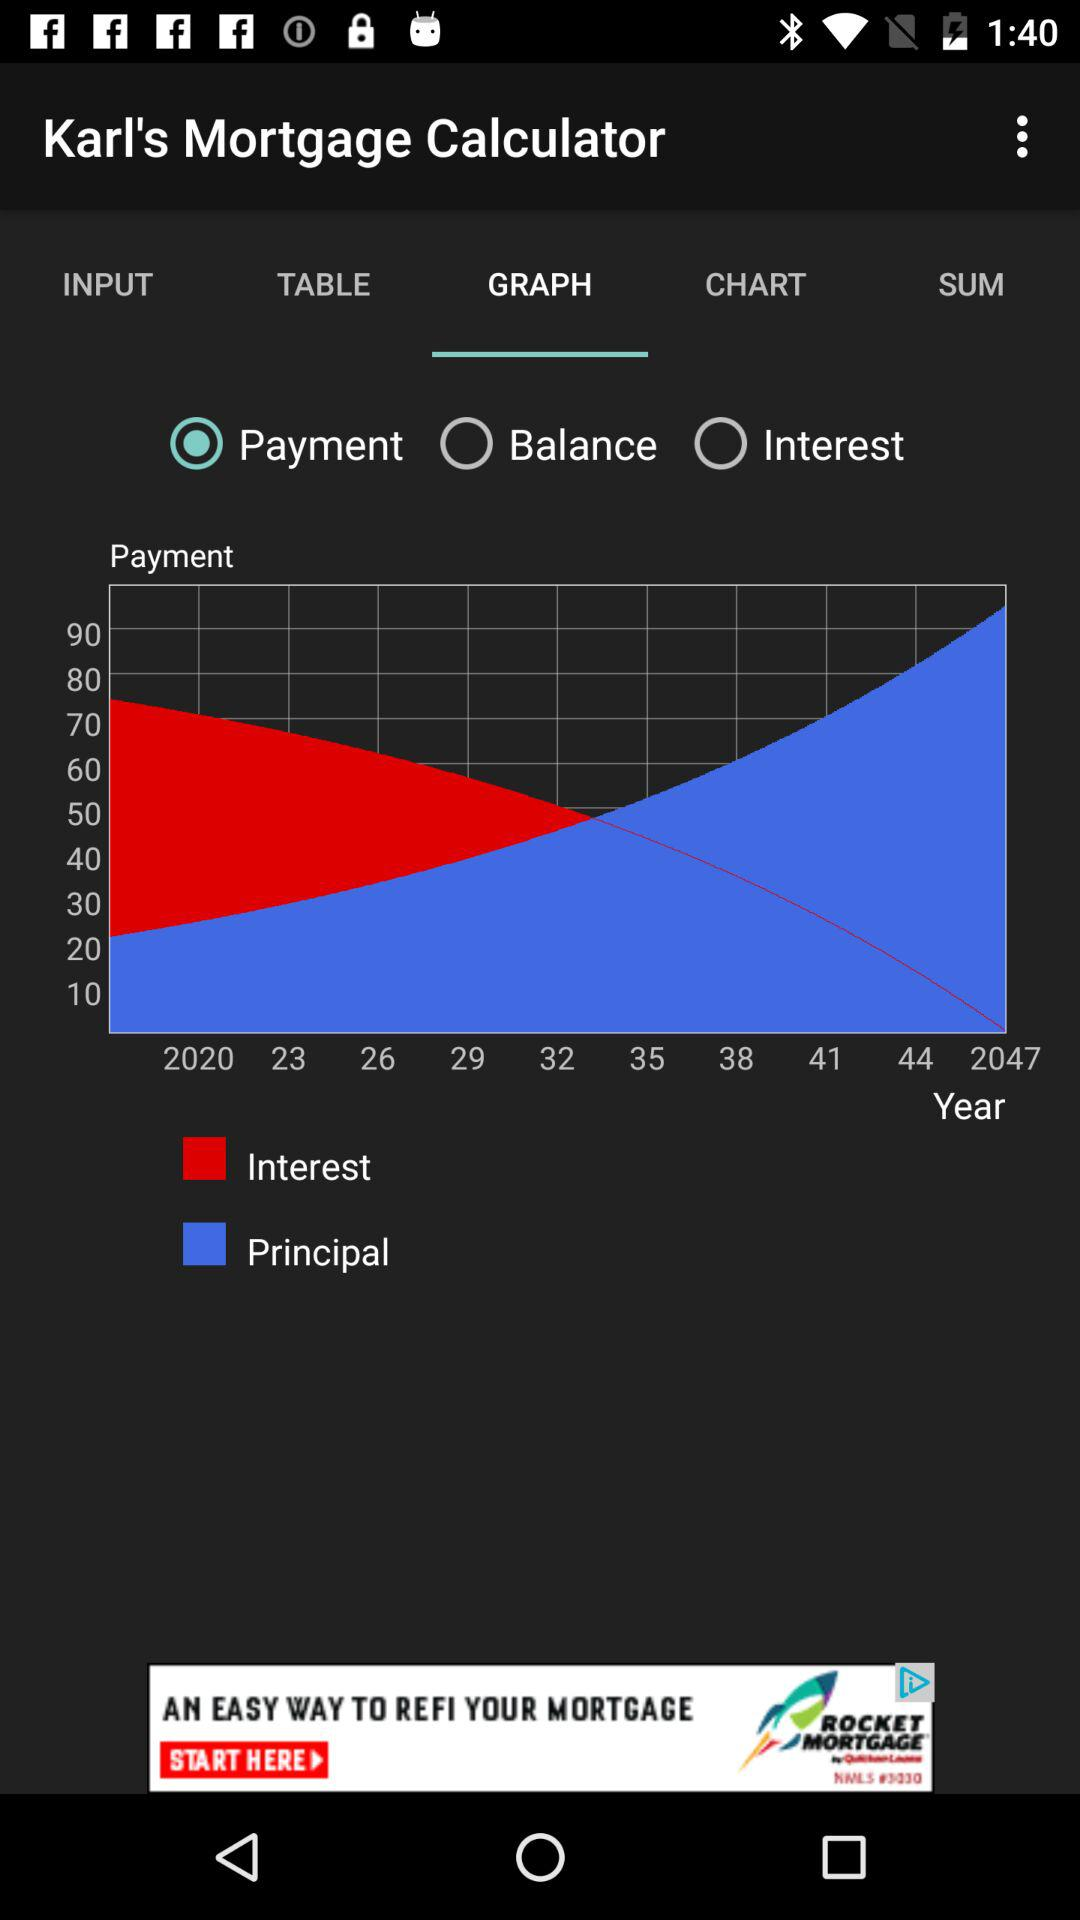What is shown in the graph as red? The red colour is shown by "Interest" in the graph. 